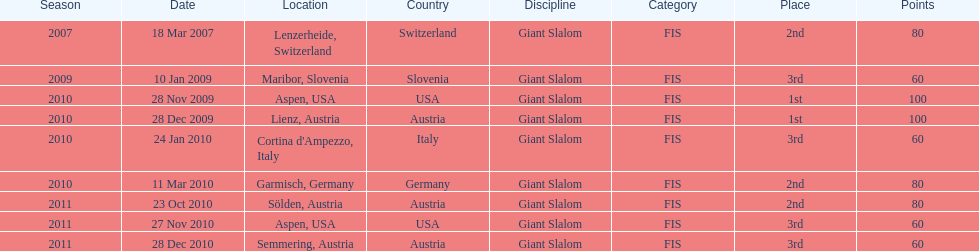Where was her first win? Aspen, USA. 